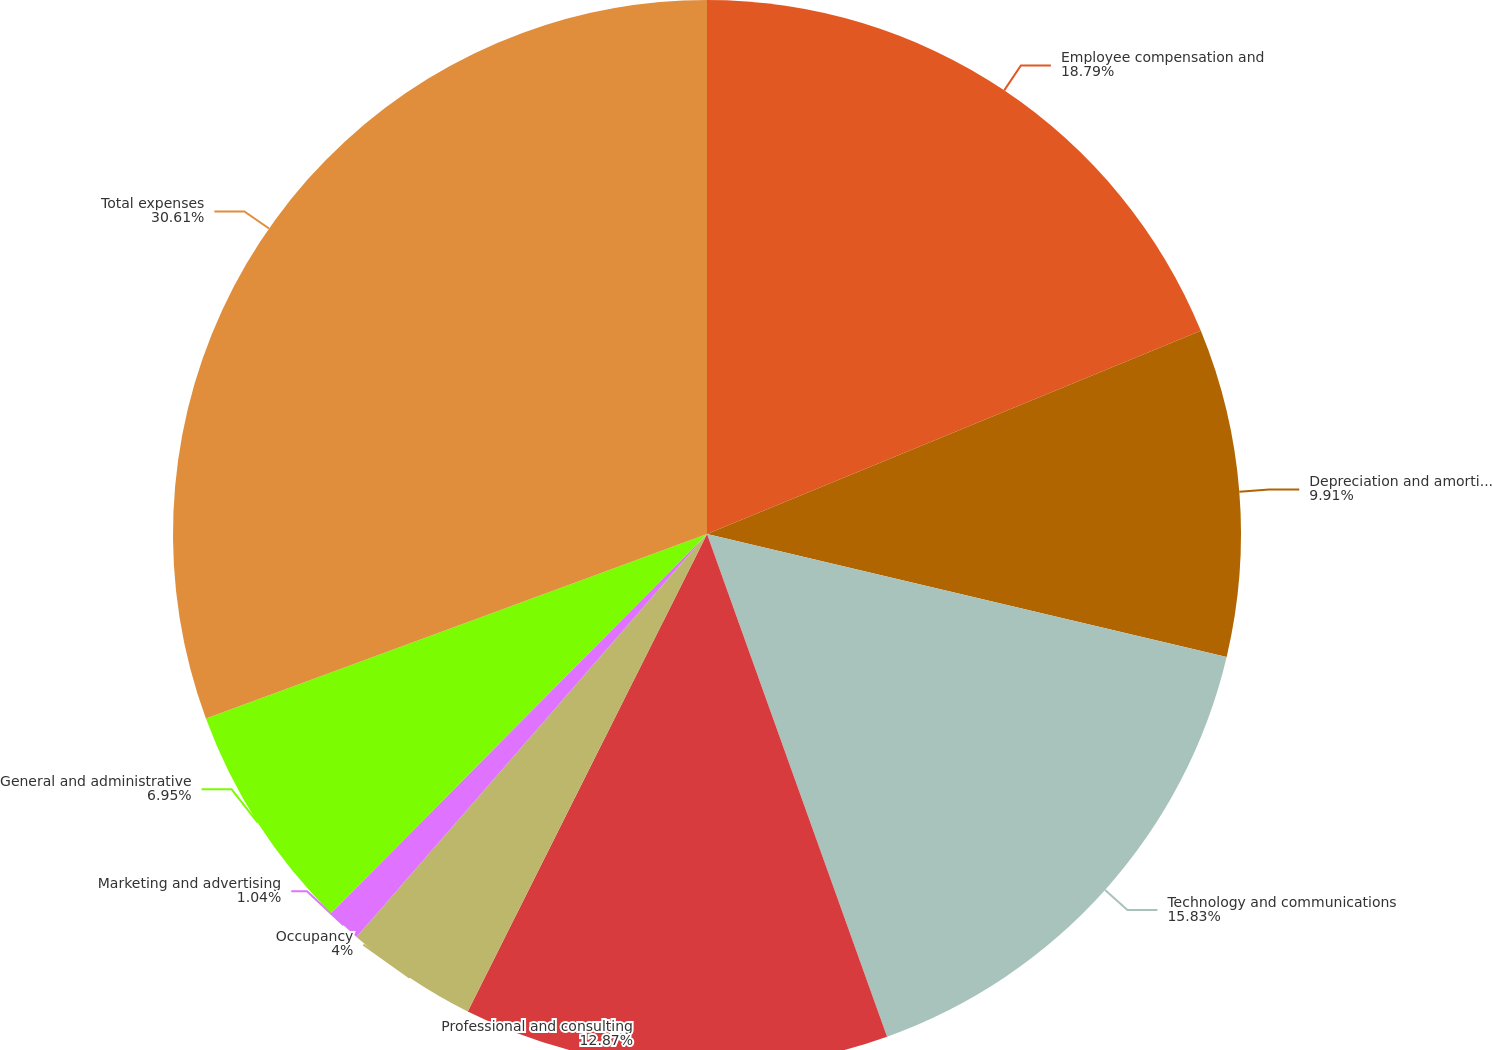Convert chart to OTSL. <chart><loc_0><loc_0><loc_500><loc_500><pie_chart><fcel>Employee compensation and<fcel>Depreciation and amortization<fcel>Technology and communications<fcel>Professional and consulting<fcel>Occupancy<fcel>Marketing and advertising<fcel>General and administrative<fcel>Total expenses<nl><fcel>18.79%<fcel>9.91%<fcel>15.83%<fcel>12.87%<fcel>4.0%<fcel>1.04%<fcel>6.95%<fcel>30.62%<nl></chart> 